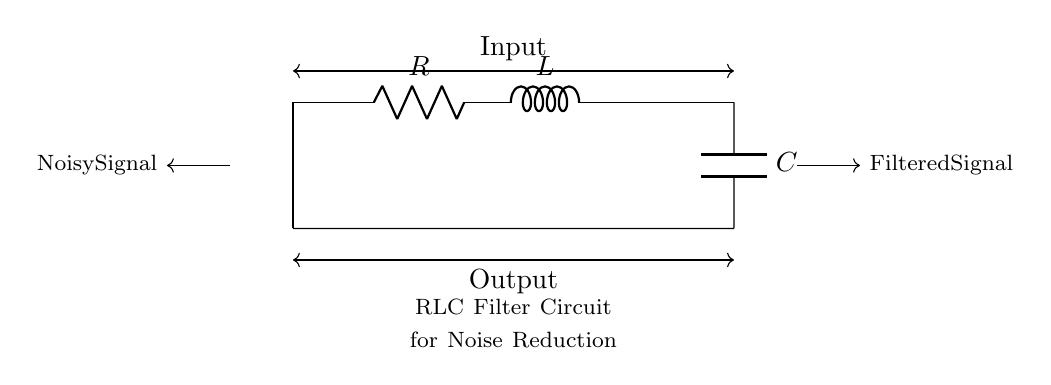What is the type of this circuit? The circuit is an RLC filter circuit, which consists of a resistor, inductor, and capacitor, arranged to filter signals and reduce noise.
Answer: RLC filter What components are present in the circuit? The circuit includes three main components: a resistor, an inductor, and a capacitor. The resistor provides resistance, the inductor provides inductance, and the capacitor provides capacitance.
Answer: Resistor, inductor, capacitor What is the direction of the input signal? The input signal enters the circuit from the left side and flows toward the right, as indicated by the arrow showing direction.
Answer: Left to right What is the purpose of this circuit? The purpose of this circuit is to reduce noise in audio systems by filtering out unwanted frequencies while allowing desired signals to pass through.
Answer: Noise reduction Which component affects the cutoff frequency? The cutoff frequency is affected by the values of the resistor, inductor, and capacitor, as they determine the frequency range that the filter will allow or reject.
Answer: Resistor, inductor, capacitor How many terminals does the capacitor have? The capacitor has two terminals, typically marked as positive and negative, where it connects to the circuit to store energy in an electric field.
Answer: Two terminals What type of signal is output from the circuit? The output signal should be a filtered signal, which has had the noise reduced compared to the input noisy signal.
Answer: Filtered signal 